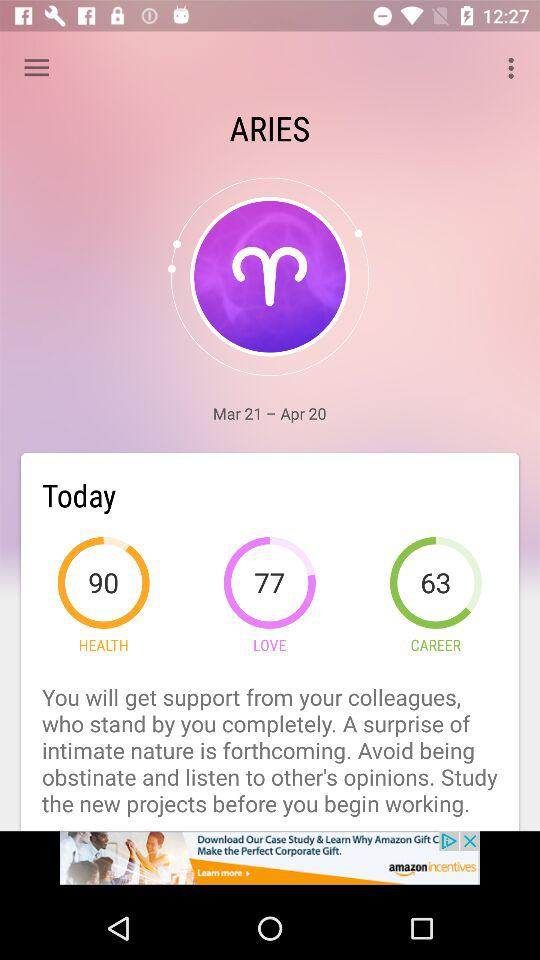What is the mentioned period? The mentioned period is from March 21 to April 20. 